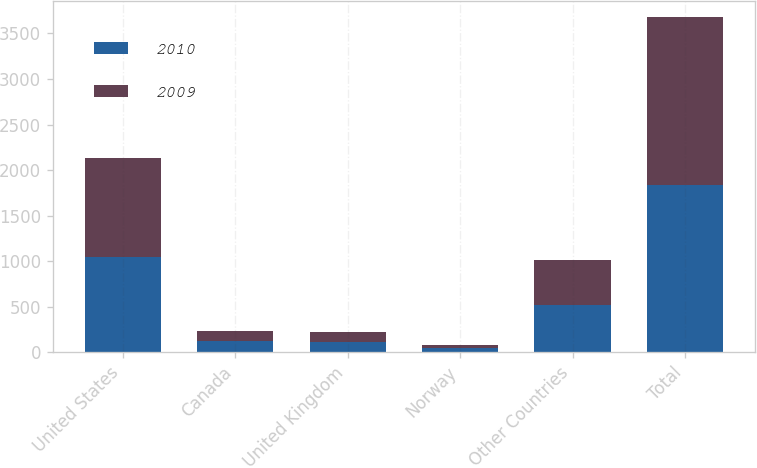Convert chart. <chart><loc_0><loc_0><loc_500><loc_500><stacked_bar_chart><ecel><fcel>United States<fcel>Canada<fcel>United Kingdom<fcel>Norway<fcel>Other Countries<fcel>Total<nl><fcel>2010<fcel>1045<fcel>118<fcel>116<fcel>40<fcel>521<fcel>1840<nl><fcel>2009<fcel>1082<fcel>116<fcel>110<fcel>41<fcel>487<fcel>1836<nl></chart> 